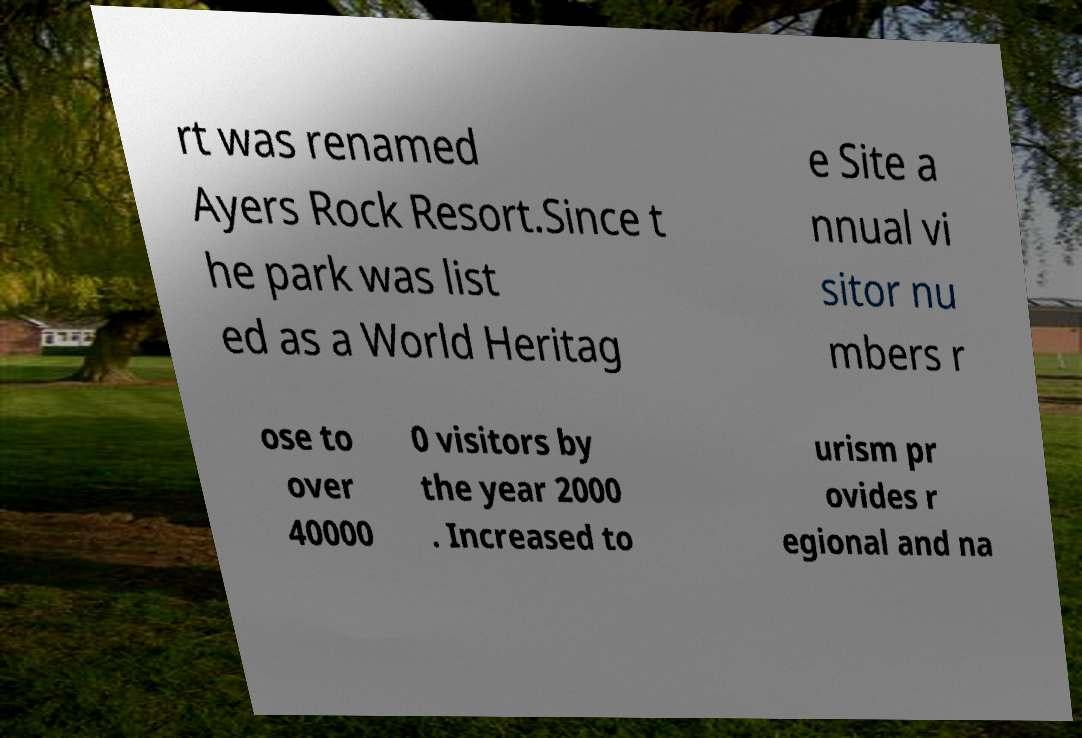Can you read and provide the text displayed in the image?This photo seems to have some interesting text. Can you extract and type it out for me? rt was renamed Ayers Rock Resort.Since t he park was list ed as a World Heritag e Site a nnual vi sitor nu mbers r ose to over 40000 0 visitors by the year 2000 . Increased to urism pr ovides r egional and na 